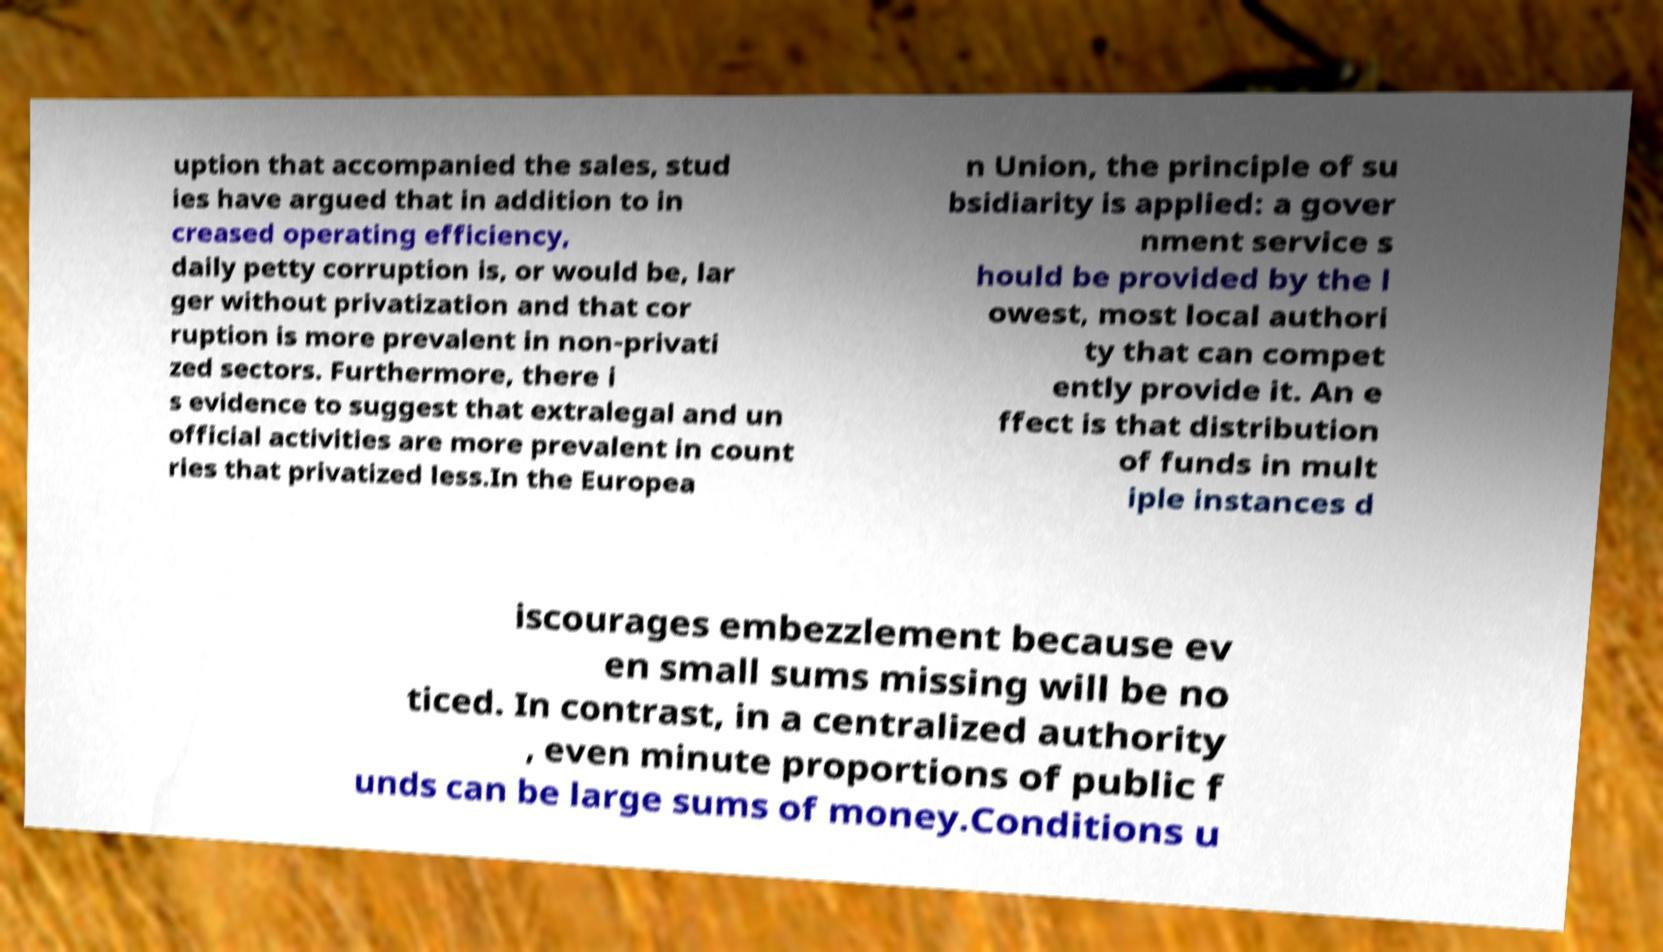What messages or text are displayed in this image? I need them in a readable, typed format. uption that accompanied the sales, stud ies have argued that in addition to in creased operating efficiency, daily petty corruption is, or would be, lar ger without privatization and that cor ruption is more prevalent in non-privati zed sectors. Furthermore, there i s evidence to suggest that extralegal and un official activities are more prevalent in count ries that privatized less.In the Europea n Union, the principle of su bsidiarity is applied: a gover nment service s hould be provided by the l owest, most local authori ty that can compet ently provide it. An e ffect is that distribution of funds in mult iple instances d iscourages embezzlement because ev en small sums missing will be no ticed. In contrast, in a centralized authority , even minute proportions of public f unds can be large sums of money.Conditions u 